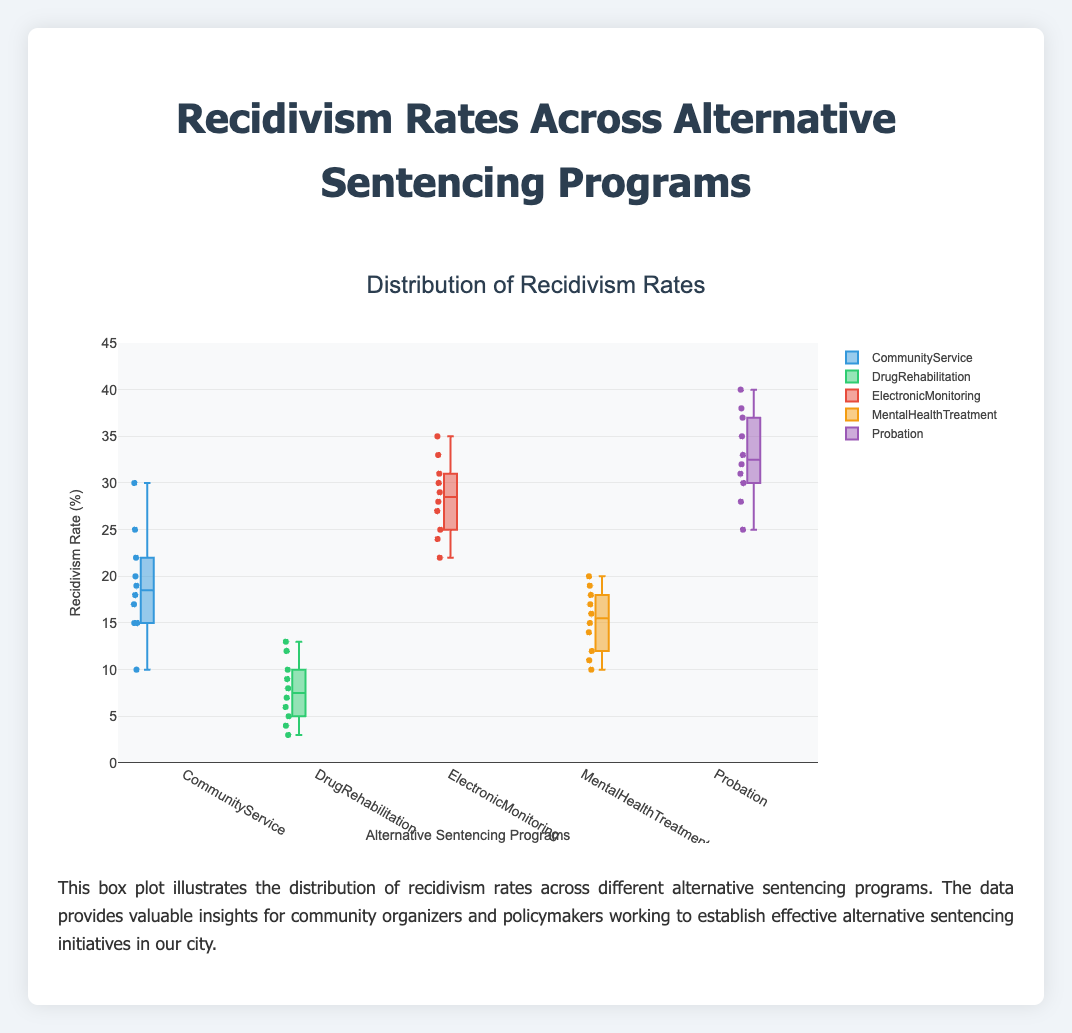What's the title of the box plot? The title of the box plot is typically located at the top of the plot and is meant to provide a clear, concise description of the plot's content. In this case, the title is "Distribution of Recidivism Rates".
Answer: Distribution of Recidivism Rates What is the range of the y-axis? The range of the y-axis is indicated by the lowest and highest values on the y-axis scale. In this plot, it spans from 0 to 45.
Answer: 0 to 45 Which program has the lowest median recidivism rate? The median recidivism rate is indicated by the line inside each box. By observing this, the lowest median is seen in the "Drug Rehabilitation" program.
Answer: Drug Rehabilitation How many alternative sentencing programs are compared in this plot? By counting the names of the groups along the x-axis, we see there are five: Community Service, Drug Rehabilitation, Electronic Monitoring, Mental Health Treatment, and Probation.
Answer: Five What is the upper quartile (75th percentile) of the Electronic Monitoring program? The upper quartile is the top edge of the box. By visual inspection, the upper quartile for Electronic Monitoring is around 31-32%.
Answer: 31-32% What's the median recidivism rate for Mental Health Treatment? The median is represented by the horizontal line inside the box. Looking at the box for Mental Health Treatment, the median is approximately 16.
Answer: 16 Which program has the widest interquartile range (IQR)? The IQR is the height of the box (distance between the 25th and 75th percentiles). The Probation program box is visually the tallest, indicating it has the widest IQR.
Answer: Probation Are there any outliers visible in the Drug Rehabilitation program? Outliers are indicated by individual points outside the whiskers. In the Drug Rehabilitation box plot, there are no such points visible.
Answer: No What is the maximum recidivism rate in the Community Service program? The maximum value is denoted by the upper whisker. For the Community Service program, the whisker extends to 30.
Answer: 30 Compare the median recidivism rates of Community Service and Probation programs. Which is higher and by how much? The median for Community Service is around 18, while for Probation it is around 33. The difference is 33 - 18 = 15.
Answer: Probation by 15 